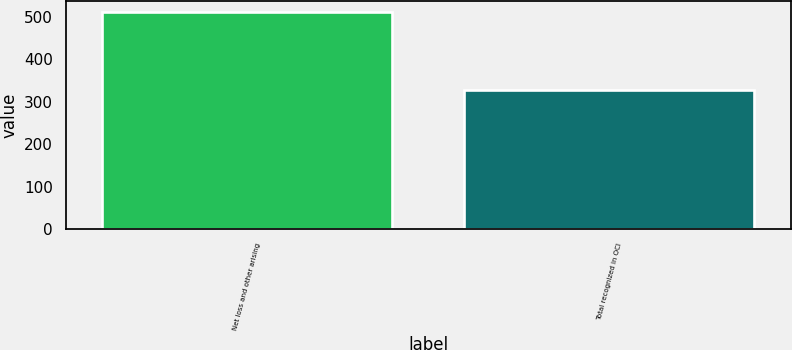Convert chart. <chart><loc_0><loc_0><loc_500><loc_500><bar_chart><fcel>Net loss and other arising<fcel>Total recognized in OCI<nl><fcel>511<fcel>327<nl></chart> 